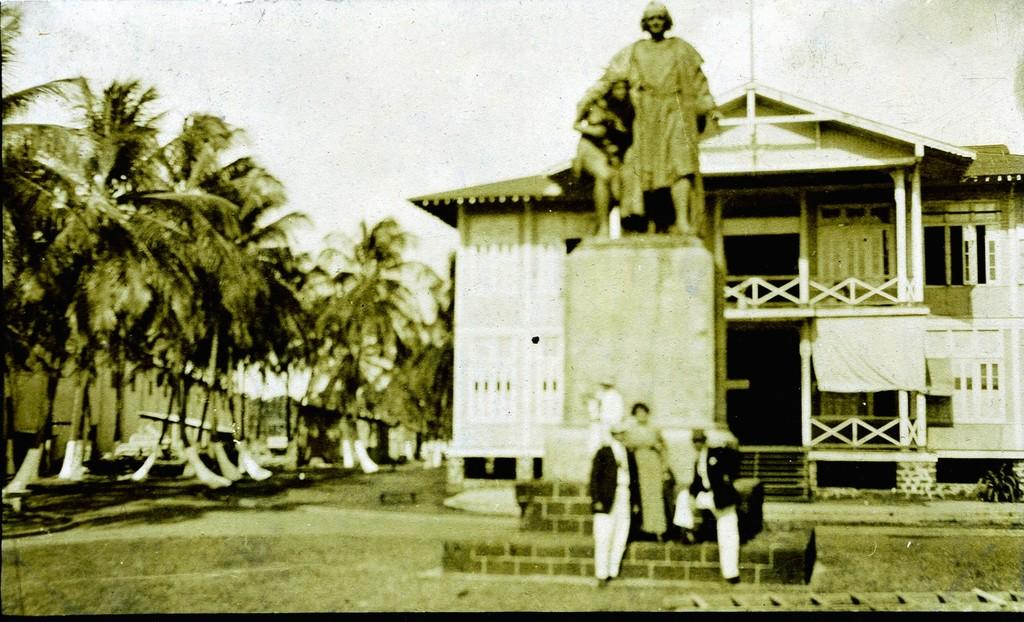How many people are present in the image? There are three people in the image. What other objects or structures can be seen in the image? There is a statue and trees visible in the image. Are there any buildings visible in the image? Yes, there are houses visible in the image. How is the statue positioned in relation to the houses? A house is located behind the statue. What type of mist can be seen surrounding the statue in the image? There is no mist present in the image; the statue and surrounding objects are clearly visible. 